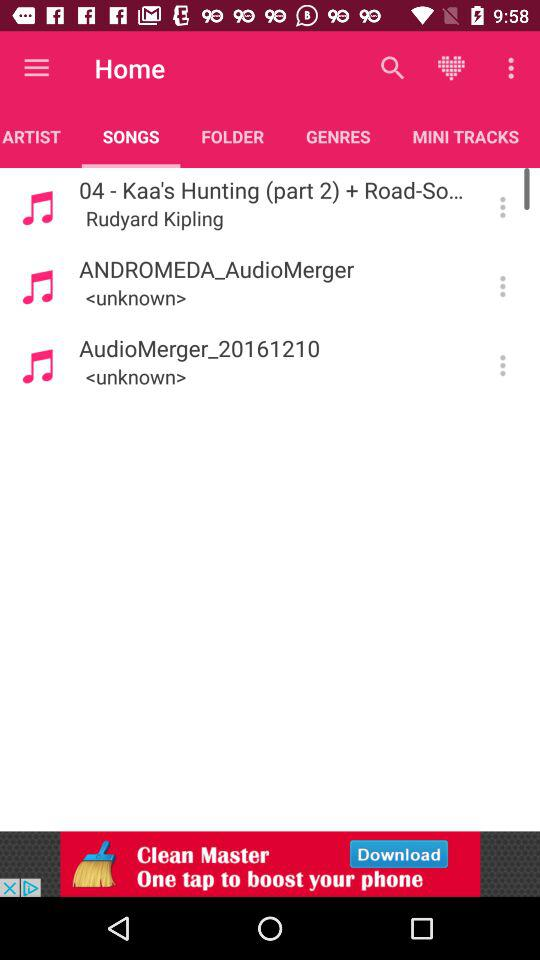Which option is selected under "Home"? The selected option is "SONGS". 